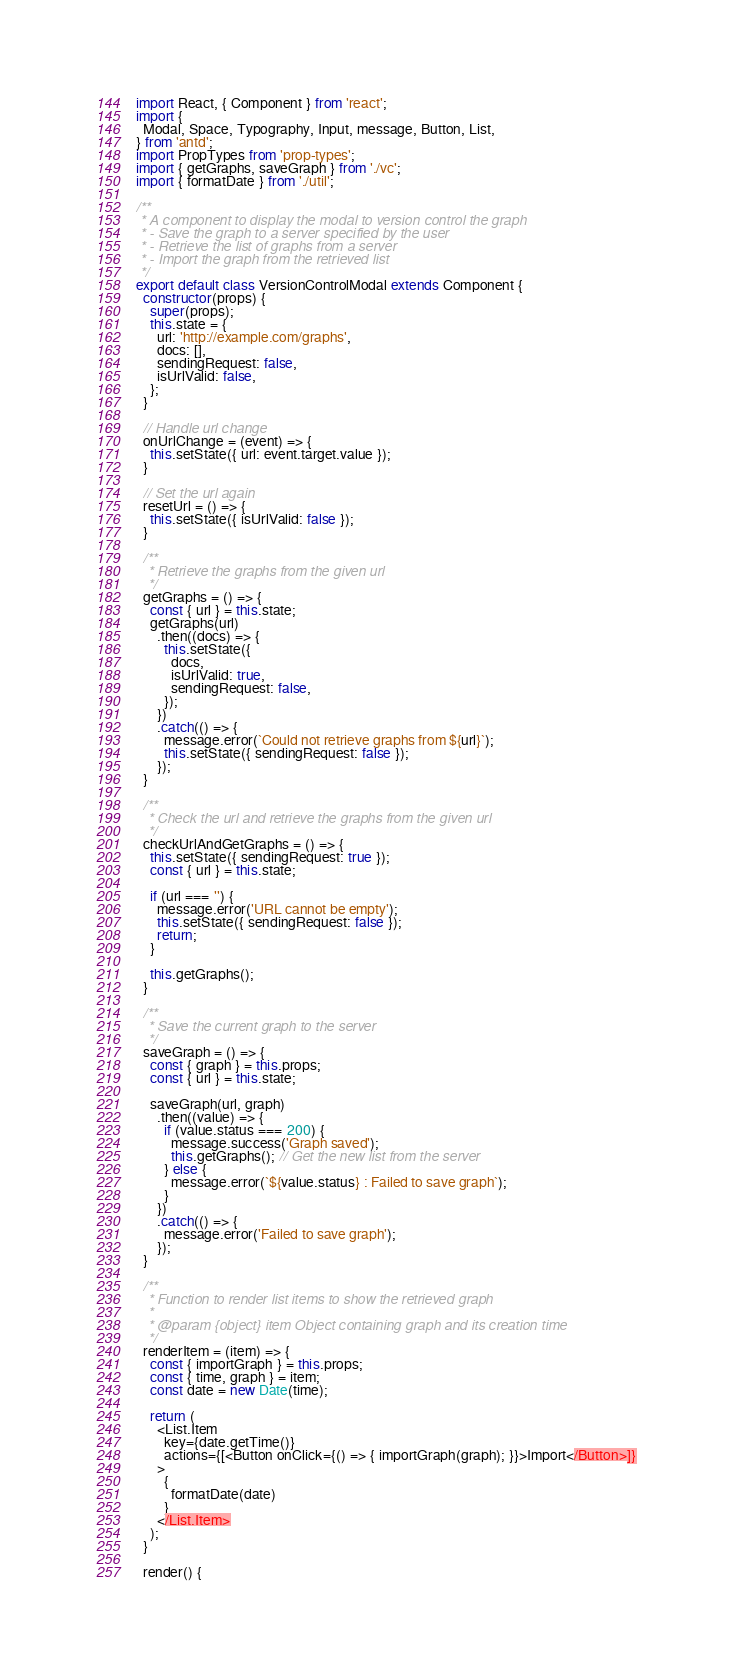Convert code to text. <code><loc_0><loc_0><loc_500><loc_500><_JavaScript_>import React, { Component } from 'react';
import {
  Modal, Space, Typography, Input, message, Button, List,
} from 'antd';
import PropTypes from 'prop-types';
import { getGraphs, saveGraph } from './vc';
import { formatDate } from './util';

/**
 * A component to display the modal to version control the graph
 * - Save the graph to a server specified by the user
 * - Retrieve the list of graphs from a server
 * - Import the graph from the retrieved list
 */
export default class VersionControlModal extends Component {
  constructor(props) {
    super(props);
    this.state = {
      url: 'http://example.com/graphs',
      docs: [],
      sendingRequest: false,
      isUrlValid: false,
    };
  }

  // Handle url change
  onUrlChange = (event) => {
    this.setState({ url: event.target.value });
  }

  // Set the url again
  resetUrl = () => {
    this.setState({ isUrlValid: false });
  }

  /**
   * Retrieve the graphs from the given url
   */
  getGraphs = () => {
    const { url } = this.state;
    getGraphs(url)
      .then((docs) => {
        this.setState({
          docs,
          isUrlValid: true,
          sendingRequest: false,
        });
      })
      .catch(() => {
        message.error(`Could not retrieve graphs from ${url}`);
        this.setState({ sendingRequest: false });
      });
  }

  /**
   * Check the url and retrieve the graphs from the given url
   */
  checkUrlAndGetGraphs = () => {
    this.setState({ sendingRequest: true });
    const { url } = this.state;

    if (url === '') {
      message.error('URL cannot be empty');
      this.setState({ sendingRequest: false });
      return;
    }

    this.getGraphs();
  }

  /**
   * Save the current graph to the server
   */
  saveGraph = () => {
    const { graph } = this.props;
    const { url } = this.state;

    saveGraph(url, graph)
      .then((value) => {
        if (value.status === 200) {
          message.success('Graph saved');
          this.getGraphs(); // Get the new list from the server
        } else {
          message.error(`${value.status} : Failed to save graph`);
        }
      })
      .catch(() => {
        message.error('Failed to save graph');
      });
  }

  /**
   * Function to render list items to show the retrieved graph
   *
   * @param {object} item Object containing graph and its creation time
   */
  renderItem = (item) => {
    const { importGraph } = this.props;
    const { time, graph } = item;
    const date = new Date(time);

    return (
      <List.Item
        key={date.getTime()}
        actions={[<Button onClick={() => { importGraph(graph); }}>Import</Button>]}
      >
        {
          formatDate(date)
        }
      </List.Item>
    );
  }

  render() {</code> 